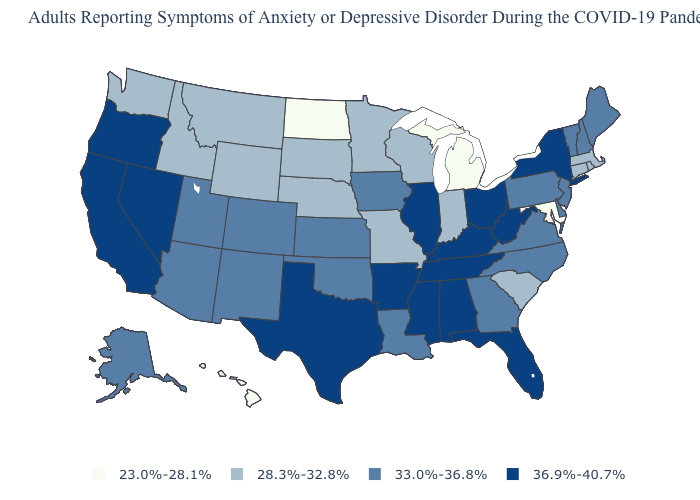Among the states that border Michigan , which have the lowest value?
Answer briefly. Indiana, Wisconsin. What is the value of New Hampshire?
Quick response, please. 33.0%-36.8%. What is the value of New Hampshire?
Keep it brief. 33.0%-36.8%. Among the states that border Delaware , does New Jersey have the lowest value?
Concise answer only. No. Which states have the highest value in the USA?
Answer briefly. Alabama, Arkansas, California, Florida, Illinois, Kentucky, Mississippi, Nevada, New York, Ohio, Oregon, Tennessee, Texas, West Virginia. Does Nevada have the same value as Massachusetts?
Give a very brief answer. No. Name the states that have a value in the range 23.0%-28.1%?
Keep it brief. Hawaii, Maryland, Michigan, North Dakota. What is the value of North Dakota?
Be succinct. 23.0%-28.1%. Name the states that have a value in the range 23.0%-28.1%?
Give a very brief answer. Hawaii, Maryland, Michigan, North Dakota. Does the map have missing data?
Give a very brief answer. No. Does North Dakota have the lowest value in the MidWest?
Be succinct. Yes. What is the value of Indiana?
Give a very brief answer. 28.3%-32.8%. How many symbols are there in the legend?
Give a very brief answer. 4. Does Delaware have the highest value in the South?
Answer briefly. No. Does Hawaii have the lowest value in the USA?
Write a very short answer. Yes. 